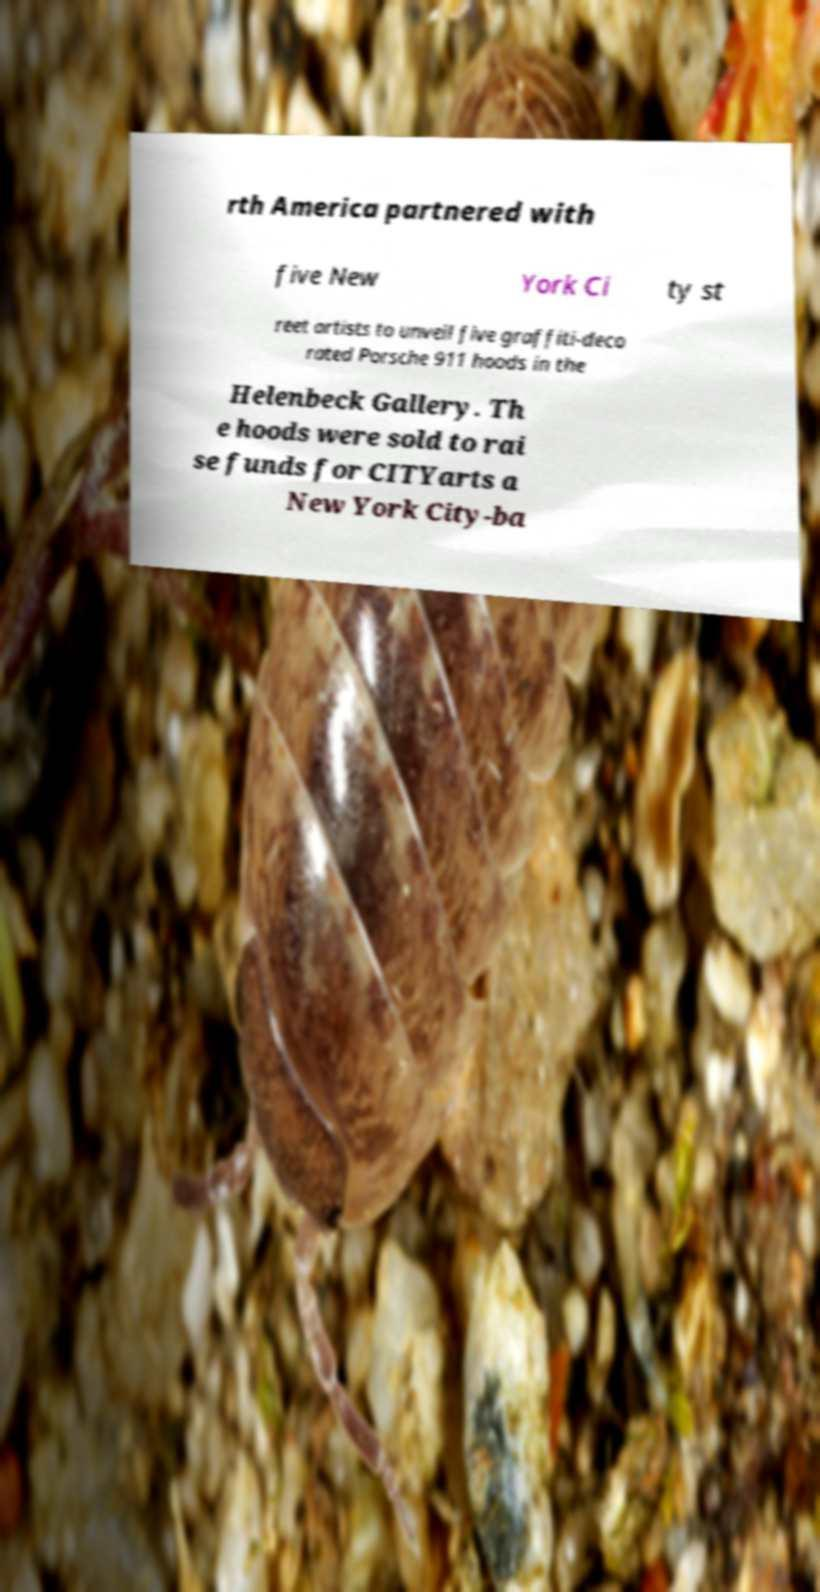Could you extract and type out the text from this image? rth America partnered with five New York Ci ty st reet artists to unveil five graffiti-deco rated Porsche 911 hoods in the Helenbeck Gallery. Th e hoods were sold to rai se funds for CITYarts a New York City-ba 